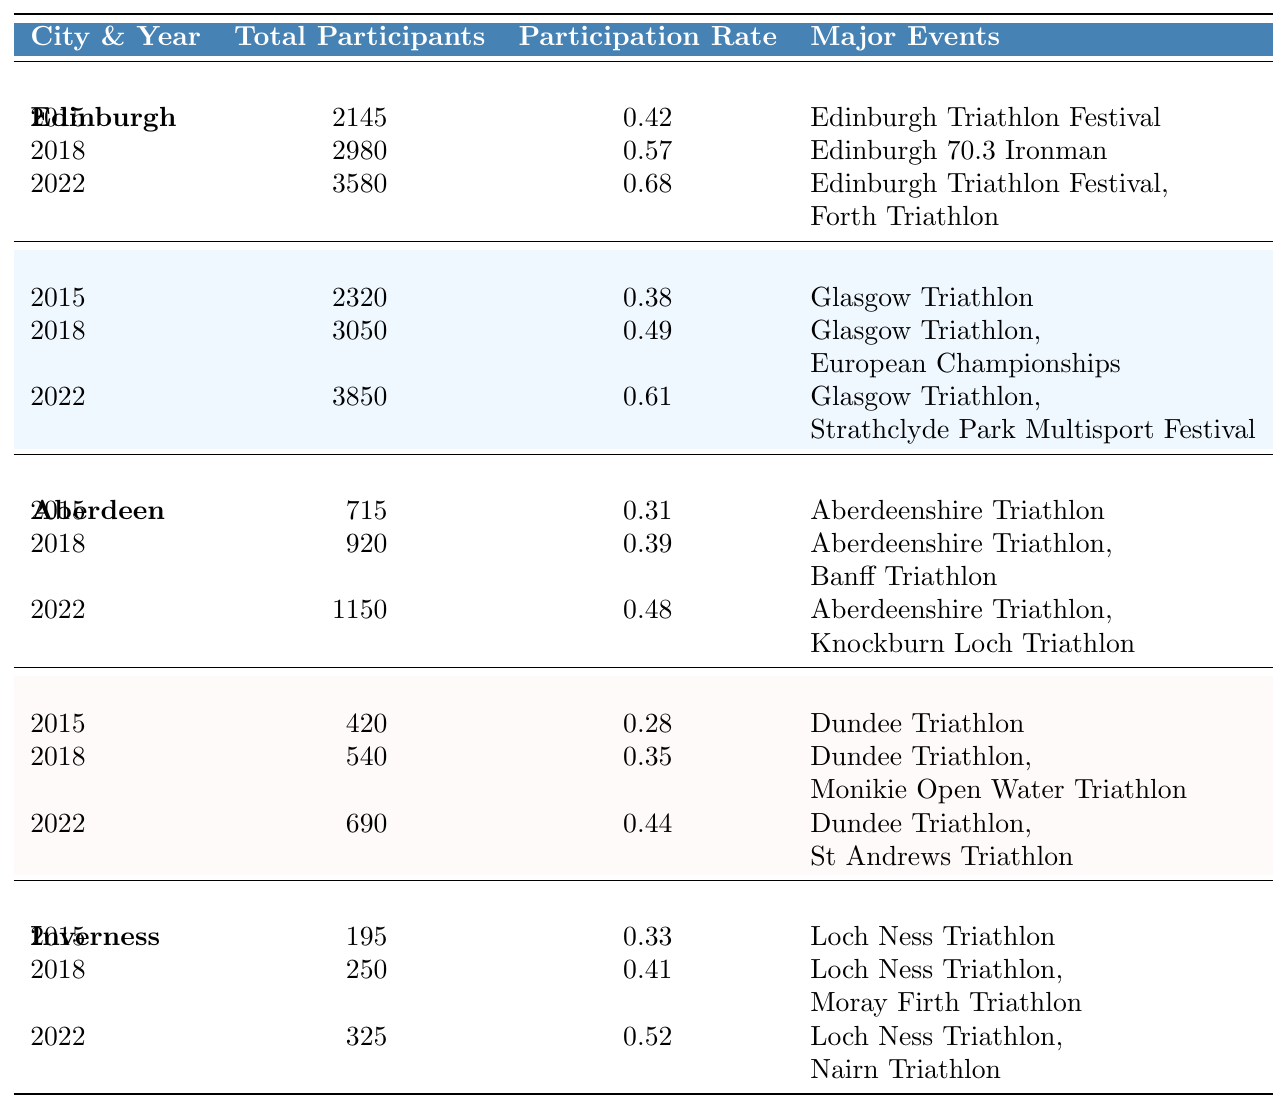What was the total number of participants in Edinburgh in 2018? The table shows that in 2018, the total number of participants in Edinburgh was listed as 2980.
Answer: 2980 Which city had the highest participation rate in 2022? By comparing the participation rates in 2022 across all cities provided in the table, Edinburgh had the highest participation rate at 0.68.
Answer: Edinburgh What was the increase in participation rate for Glasgow from 2015 to 2022? The participation rate for Glasgow in 2015 was 0.38, and in 2022 it was 0.61. The increase is calculated by subtracting 0.38 from 0.61, yielding an increase of 0.23.
Answer: 0.23 Did Aberdeen have more total participants in 2022 than in 2018? In the table, Aberdeen had 1150 total participants in 2022 and 920 in 2018. Thus, 1150 is greater than 920, so the answer is yes.
Answer: Yes What is the average participation rate across all cities in 2022? The participation rates in 2022 for the cities are 0.68 (Edinburgh), 0.61 (Glasgow), 0.48 (Aberdeen), 0.44 (Dundee), and 0.52 (Inverness). Adding these gives 0.68 + 0.61 + 0.48 + 0.44 + 0.52 = 2.73, and dividing by 5 (the number of cities) gives an average participation rate of 0.546.
Answer: 0.546 Which city had the lowest total participants in 2015? By checking the total participants for each city in 2015, Dundee had the lowest with a total of 420 participants.
Answer: Dundee How much did the total number of participants grow in Edinburgh from 2015 to 2022? The total number of participants in Edinburgh was 2145 in 2015 and grew to 3580 in 2022. The growth is calculated as 3580 - 2145 = 1435.
Answer: 1435 What was the major event for Dundee in 2018? The table states that in 2018, the major event for Dundee was the Dundee Triathlon and Monikie Open Water Triathlon.
Answer: Dundee Triathlon, Monikie Open Water Triathlon Did Inverness's participation rate increase in every measurement from 2015 to 2022? To ascertain this, compare the participation rates: 0.33 in 2015, 0.41 in 2018, and 0.52 in 2022. Since all values are increasing, the answer is yes.
Answer: Yes Calculate the difference in total participants between the highest (Glasgow) and the lowest (Dundee) in 2022. In 2022, Glasgow had 3850 participants and Dundee had 690. The difference is calculated as 3850 - 690 = 3160.
Answer: 3160 What was the trend of participation rates across the years for each city? Analyzing the data, participation rates increased in every city from 2015 to 2022, indicating a growing trend in participation.
Answer: Increasing trend 